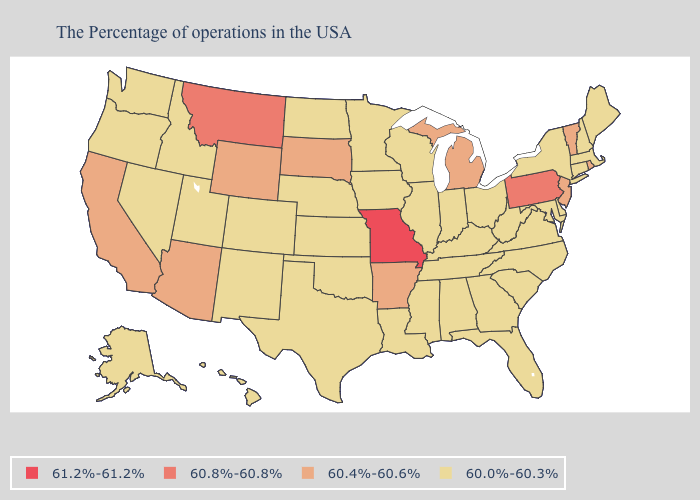Name the states that have a value in the range 60.8%-60.8%?
Keep it brief. Pennsylvania, Montana. What is the lowest value in the West?
Short answer required. 60.0%-60.3%. What is the value of Nebraska?
Be succinct. 60.0%-60.3%. How many symbols are there in the legend?
Be succinct. 4. Among the states that border Indiana , does Kentucky have the lowest value?
Concise answer only. Yes. Name the states that have a value in the range 60.8%-60.8%?
Be succinct. Pennsylvania, Montana. Name the states that have a value in the range 60.8%-60.8%?
Quick response, please. Pennsylvania, Montana. What is the value of Florida?
Keep it brief. 60.0%-60.3%. What is the value of Kentucky?
Keep it brief. 60.0%-60.3%. What is the value of Hawaii?
Answer briefly. 60.0%-60.3%. Does Missouri have the highest value in the USA?
Short answer required. Yes. Name the states that have a value in the range 60.4%-60.6%?
Write a very short answer. Rhode Island, Vermont, New Jersey, Michigan, Arkansas, South Dakota, Wyoming, Arizona, California. Among the states that border Missouri , does Nebraska have the highest value?
Quick response, please. No. What is the highest value in states that border Indiana?
Short answer required. 60.4%-60.6%. Does Louisiana have the lowest value in the South?
Keep it brief. Yes. 